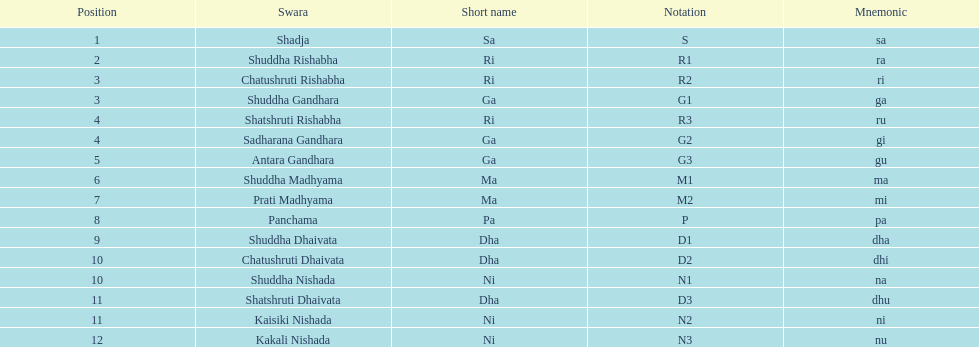Excluding m1, in how many notations does the digit "1" appear? 4. 